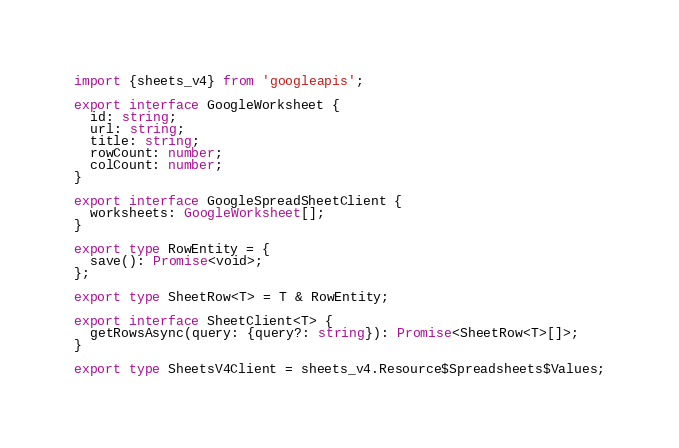Convert code to text. <code><loc_0><loc_0><loc_500><loc_500><_TypeScript_>import {sheets_v4} from 'googleapis';

export interface GoogleWorksheet {
  id: string;
  url: string;
  title: string;
  rowCount: number;
  colCount: number;
}

export interface GoogleSpreadSheetClient {
  worksheets: GoogleWorksheet[];
}

export type RowEntity = {
  save(): Promise<void>;
};

export type SheetRow<T> = T & RowEntity;

export interface SheetClient<T> {
  getRowsAsync(query: {query?: string}): Promise<SheetRow<T>[]>;
}

export type SheetsV4Client = sheets_v4.Resource$Spreadsheets$Values;
</code> 